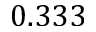Convert formula to latex. <formula><loc_0><loc_0><loc_500><loc_500>0 . 3 3 3</formula> 